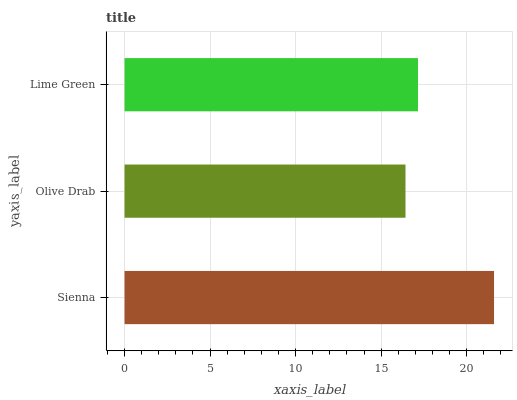Is Olive Drab the minimum?
Answer yes or no. Yes. Is Sienna the maximum?
Answer yes or no. Yes. Is Lime Green the minimum?
Answer yes or no. No. Is Lime Green the maximum?
Answer yes or no. No. Is Lime Green greater than Olive Drab?
Answer yes or no. Yes. Is Olive Drab less than Lime Green?
Answer yes or no. Yes. Is Olive Drab greater than Lime Green?
Answer yes or no. No. Is Lime Green less than Olive Drab?
Answer yes or no. No. Is Lime Green the high median?
Answer yes or no. Yes. Is Lime Green the low median?
Answer yes or no. Yes. Is Olive Drab the high median?
Answer yes or no. No. Is Olive Drab the low median?
Answer yes or no. No. 